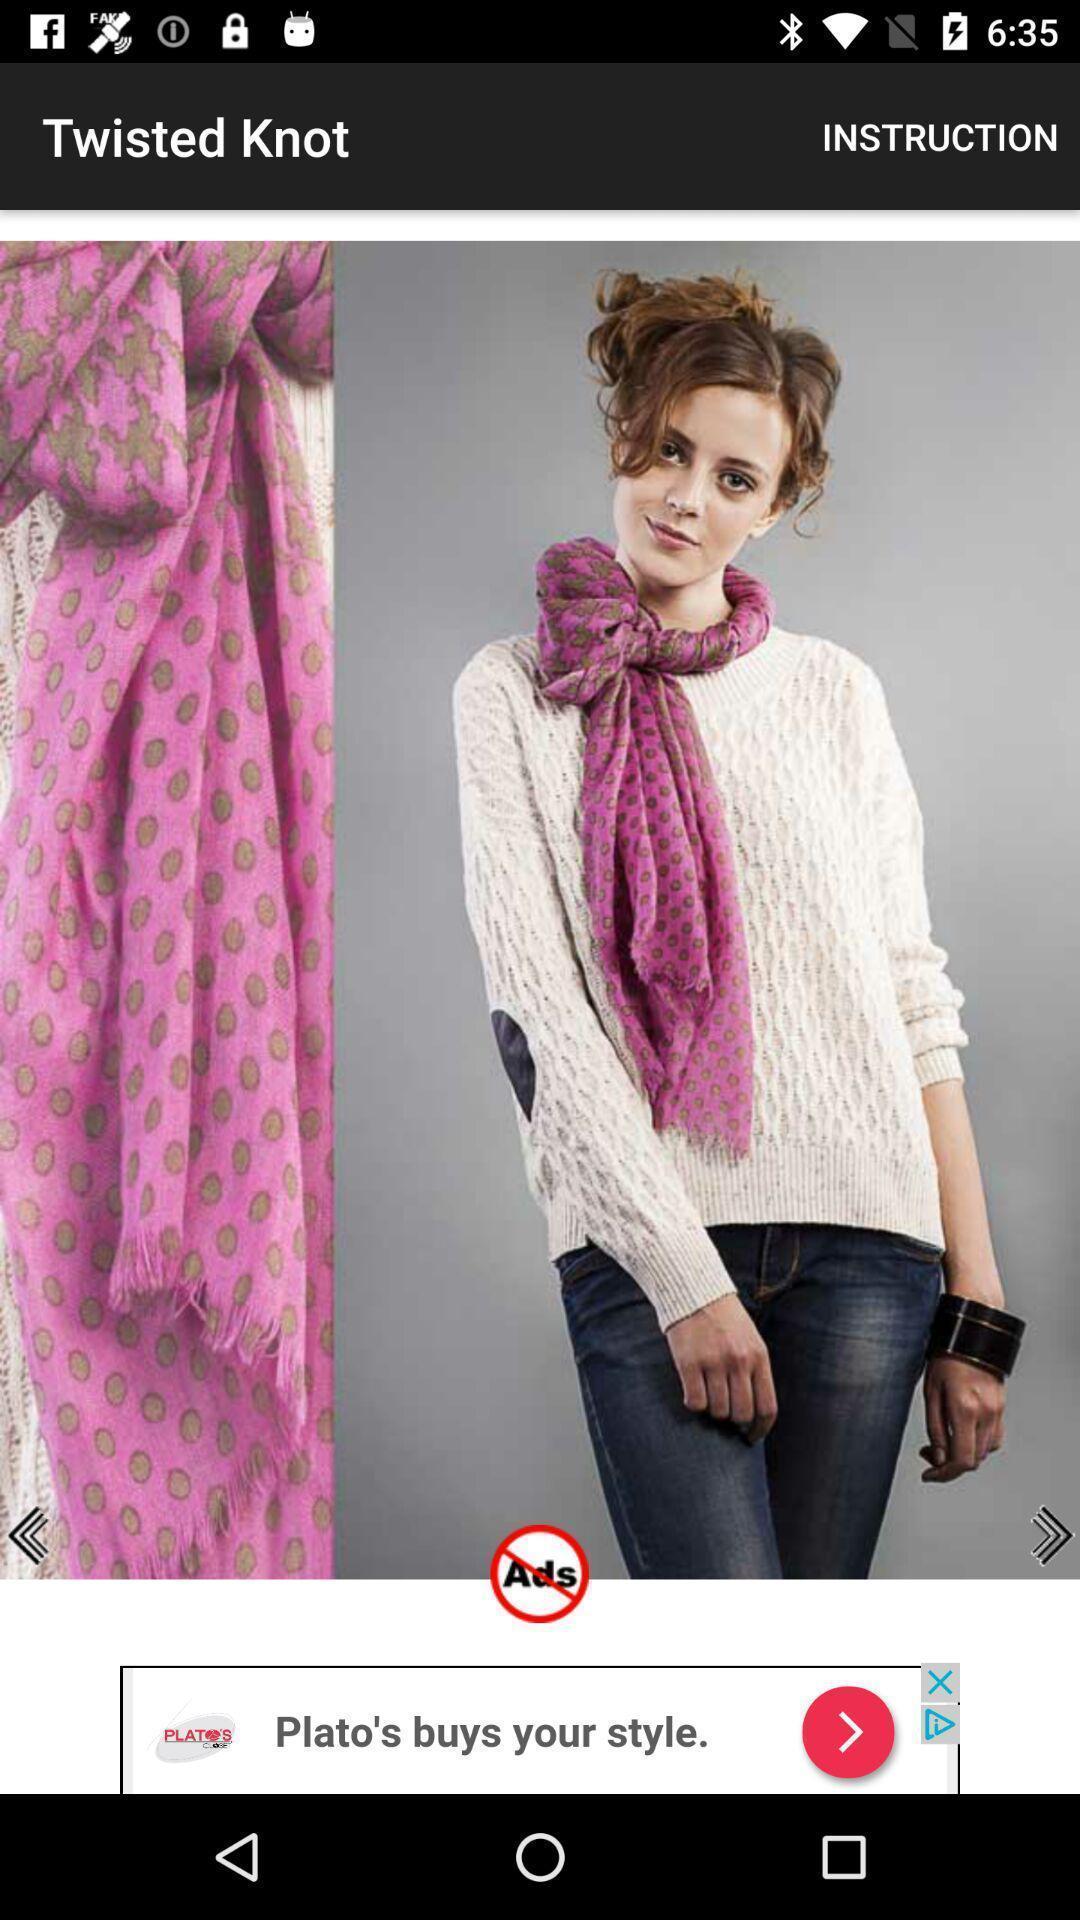Describe the key features of this screenshot. Shopping app displaying an item with other options. 